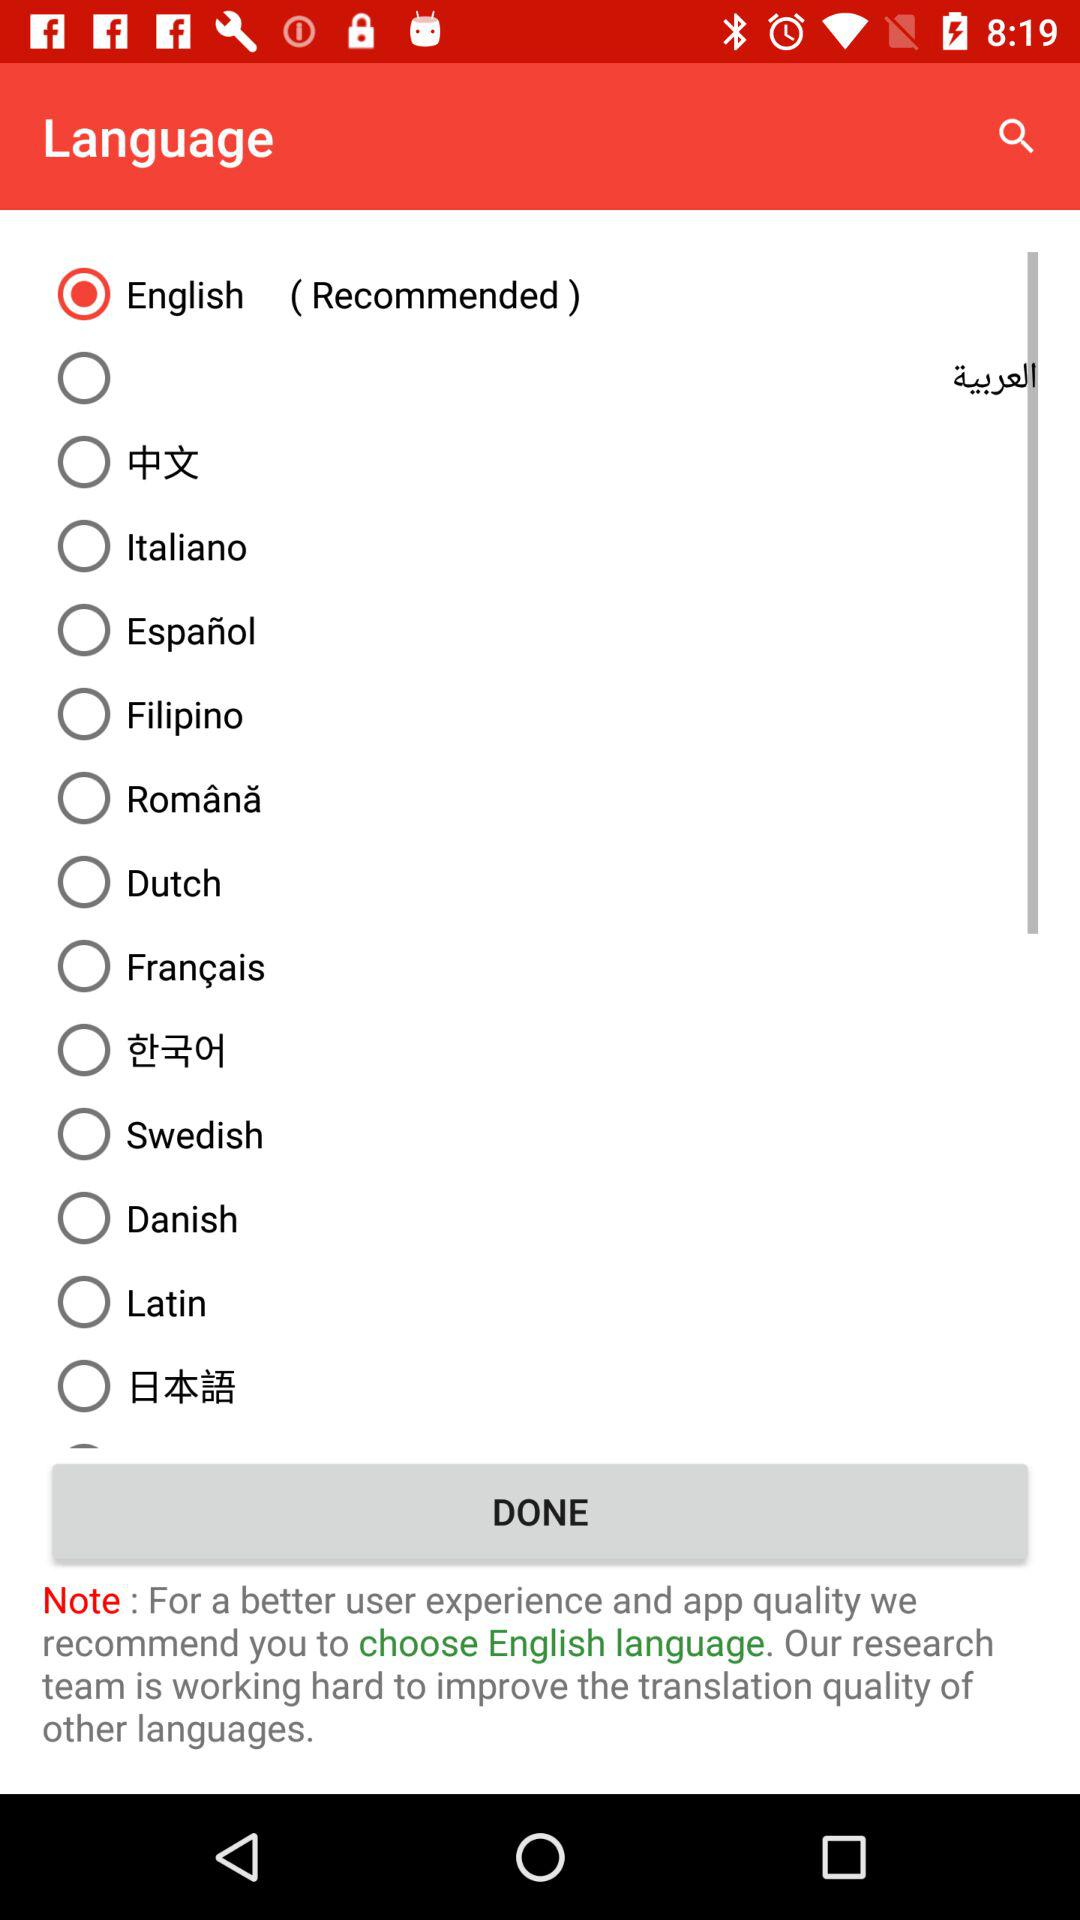Which language has been chosen? The language that has been chosen is English. 